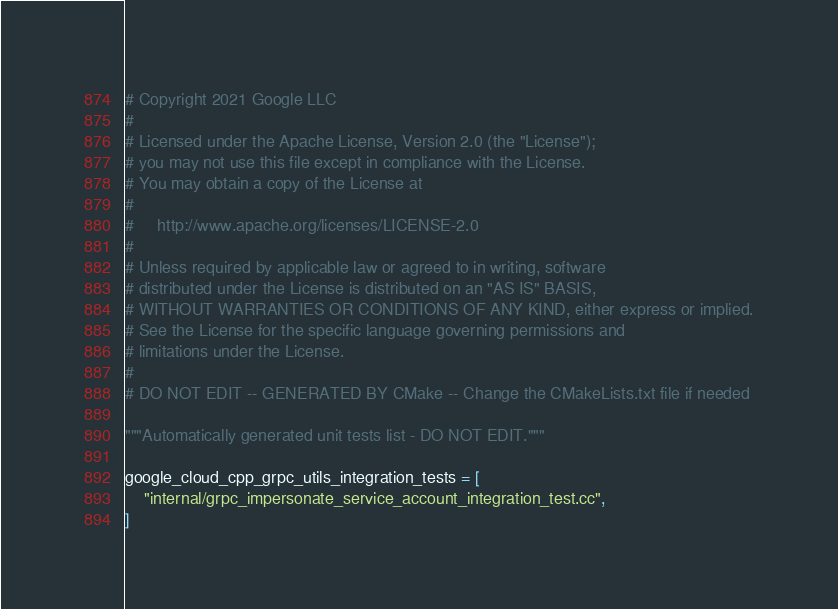Convert code to text. <code><loc_0><loc_0><loc_500><loc_500><_Python_># Copyright 2021 Google LLC
#
# Licensed under the Apache License, Version 2.0 (the "License");
# you may not use this file except in compliance with the License.
# You may obtain a copy of the License at
#
#     http://www.apache.org/licenses/LICENSE-2.0
#
# Unless required by applicable law or agreed to in writing, software
# distributed under the License is distributed on an "AS IS" BASIS,
# WITHOUT WARRANTIES OR CONDITIONS OF ANY KIND, either express or implied.
# See the License for the specific language governing permissions and
# limitations under the License.
#
# DO NOT EDIT -- GENERATED BY CMake -- Change the CMakeLists.txt file if needed

"""Automatically generated unit tests list - DO NOT EDIT."""

google_cloud_cpp_grpc_utils_integration_tests = [
    "internal/grpc_impersonate_service_account_integration_test.cc",
]
</code> 